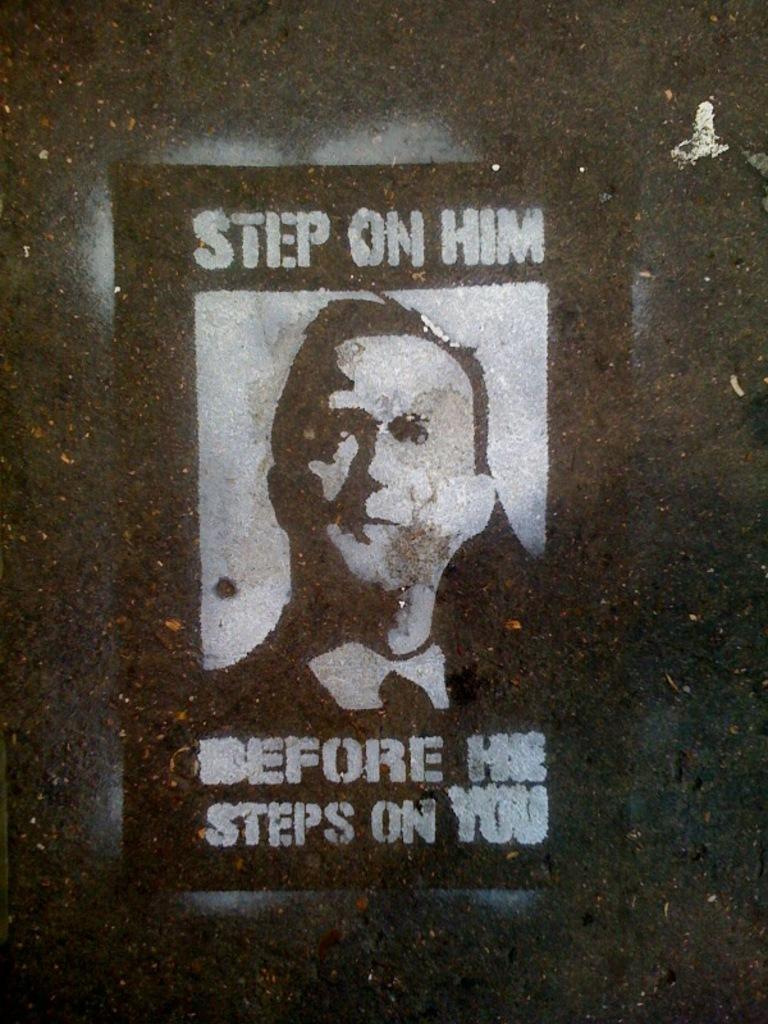Can you describe this image briefly? In this picture we can see a poster, there is a picture of a person and some text on the poster. 